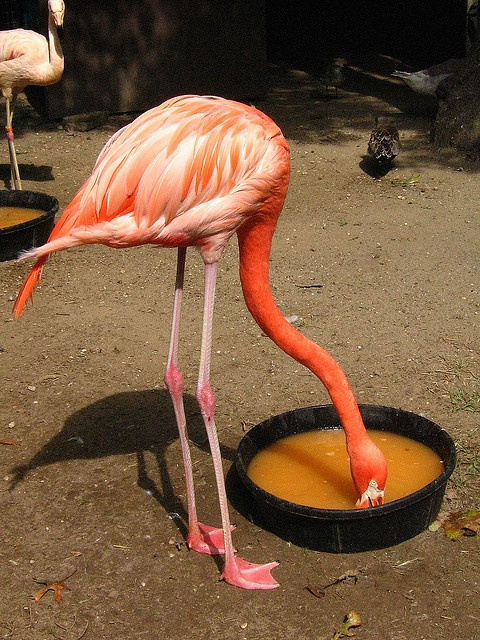Describe the objects in this image and their specific colors. I can see bird in black, salmon, tan, and red tones, bowl in black, red, and orange tones, bird in black, tan, beige, and maroon tones, bowl in black, olive, and maroon tones, and bird in black, gray, and darkgreen tones in this image. 